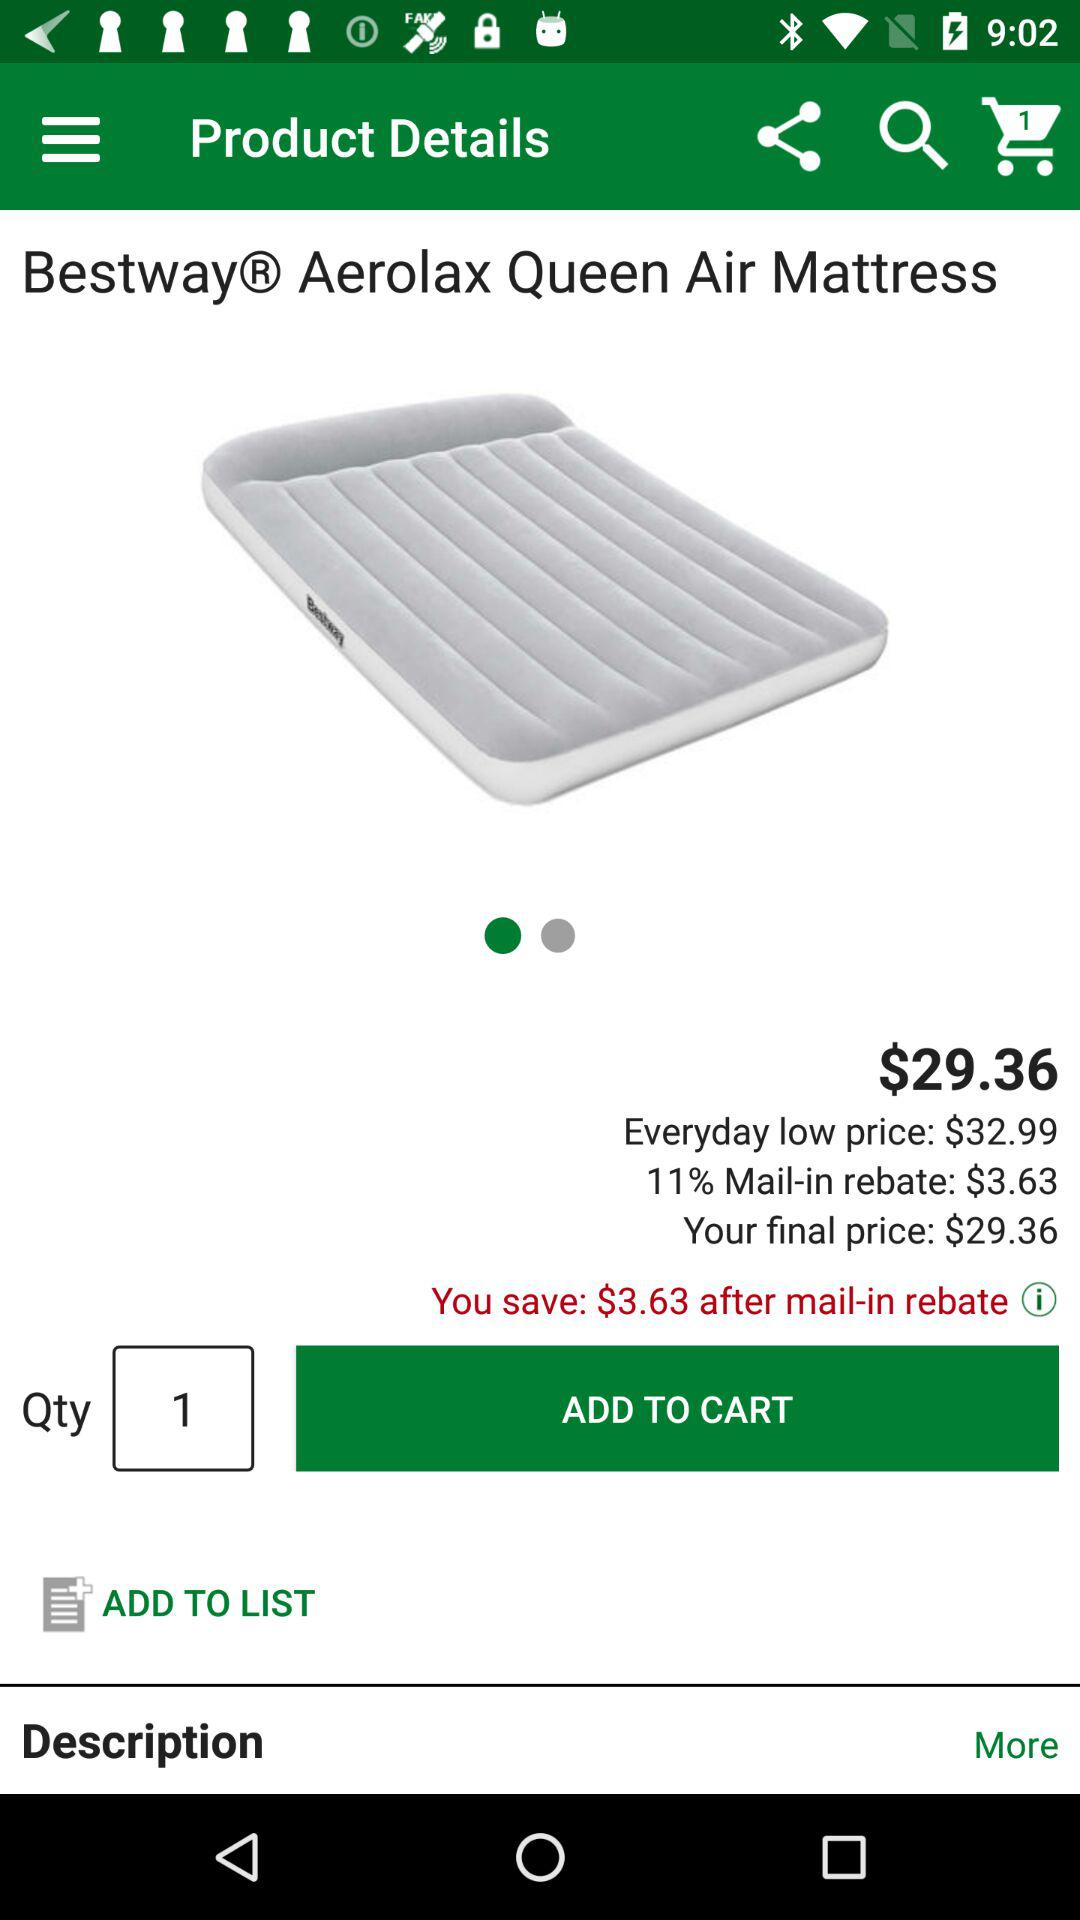What is the price of the product? The price of the product is $29.36. 